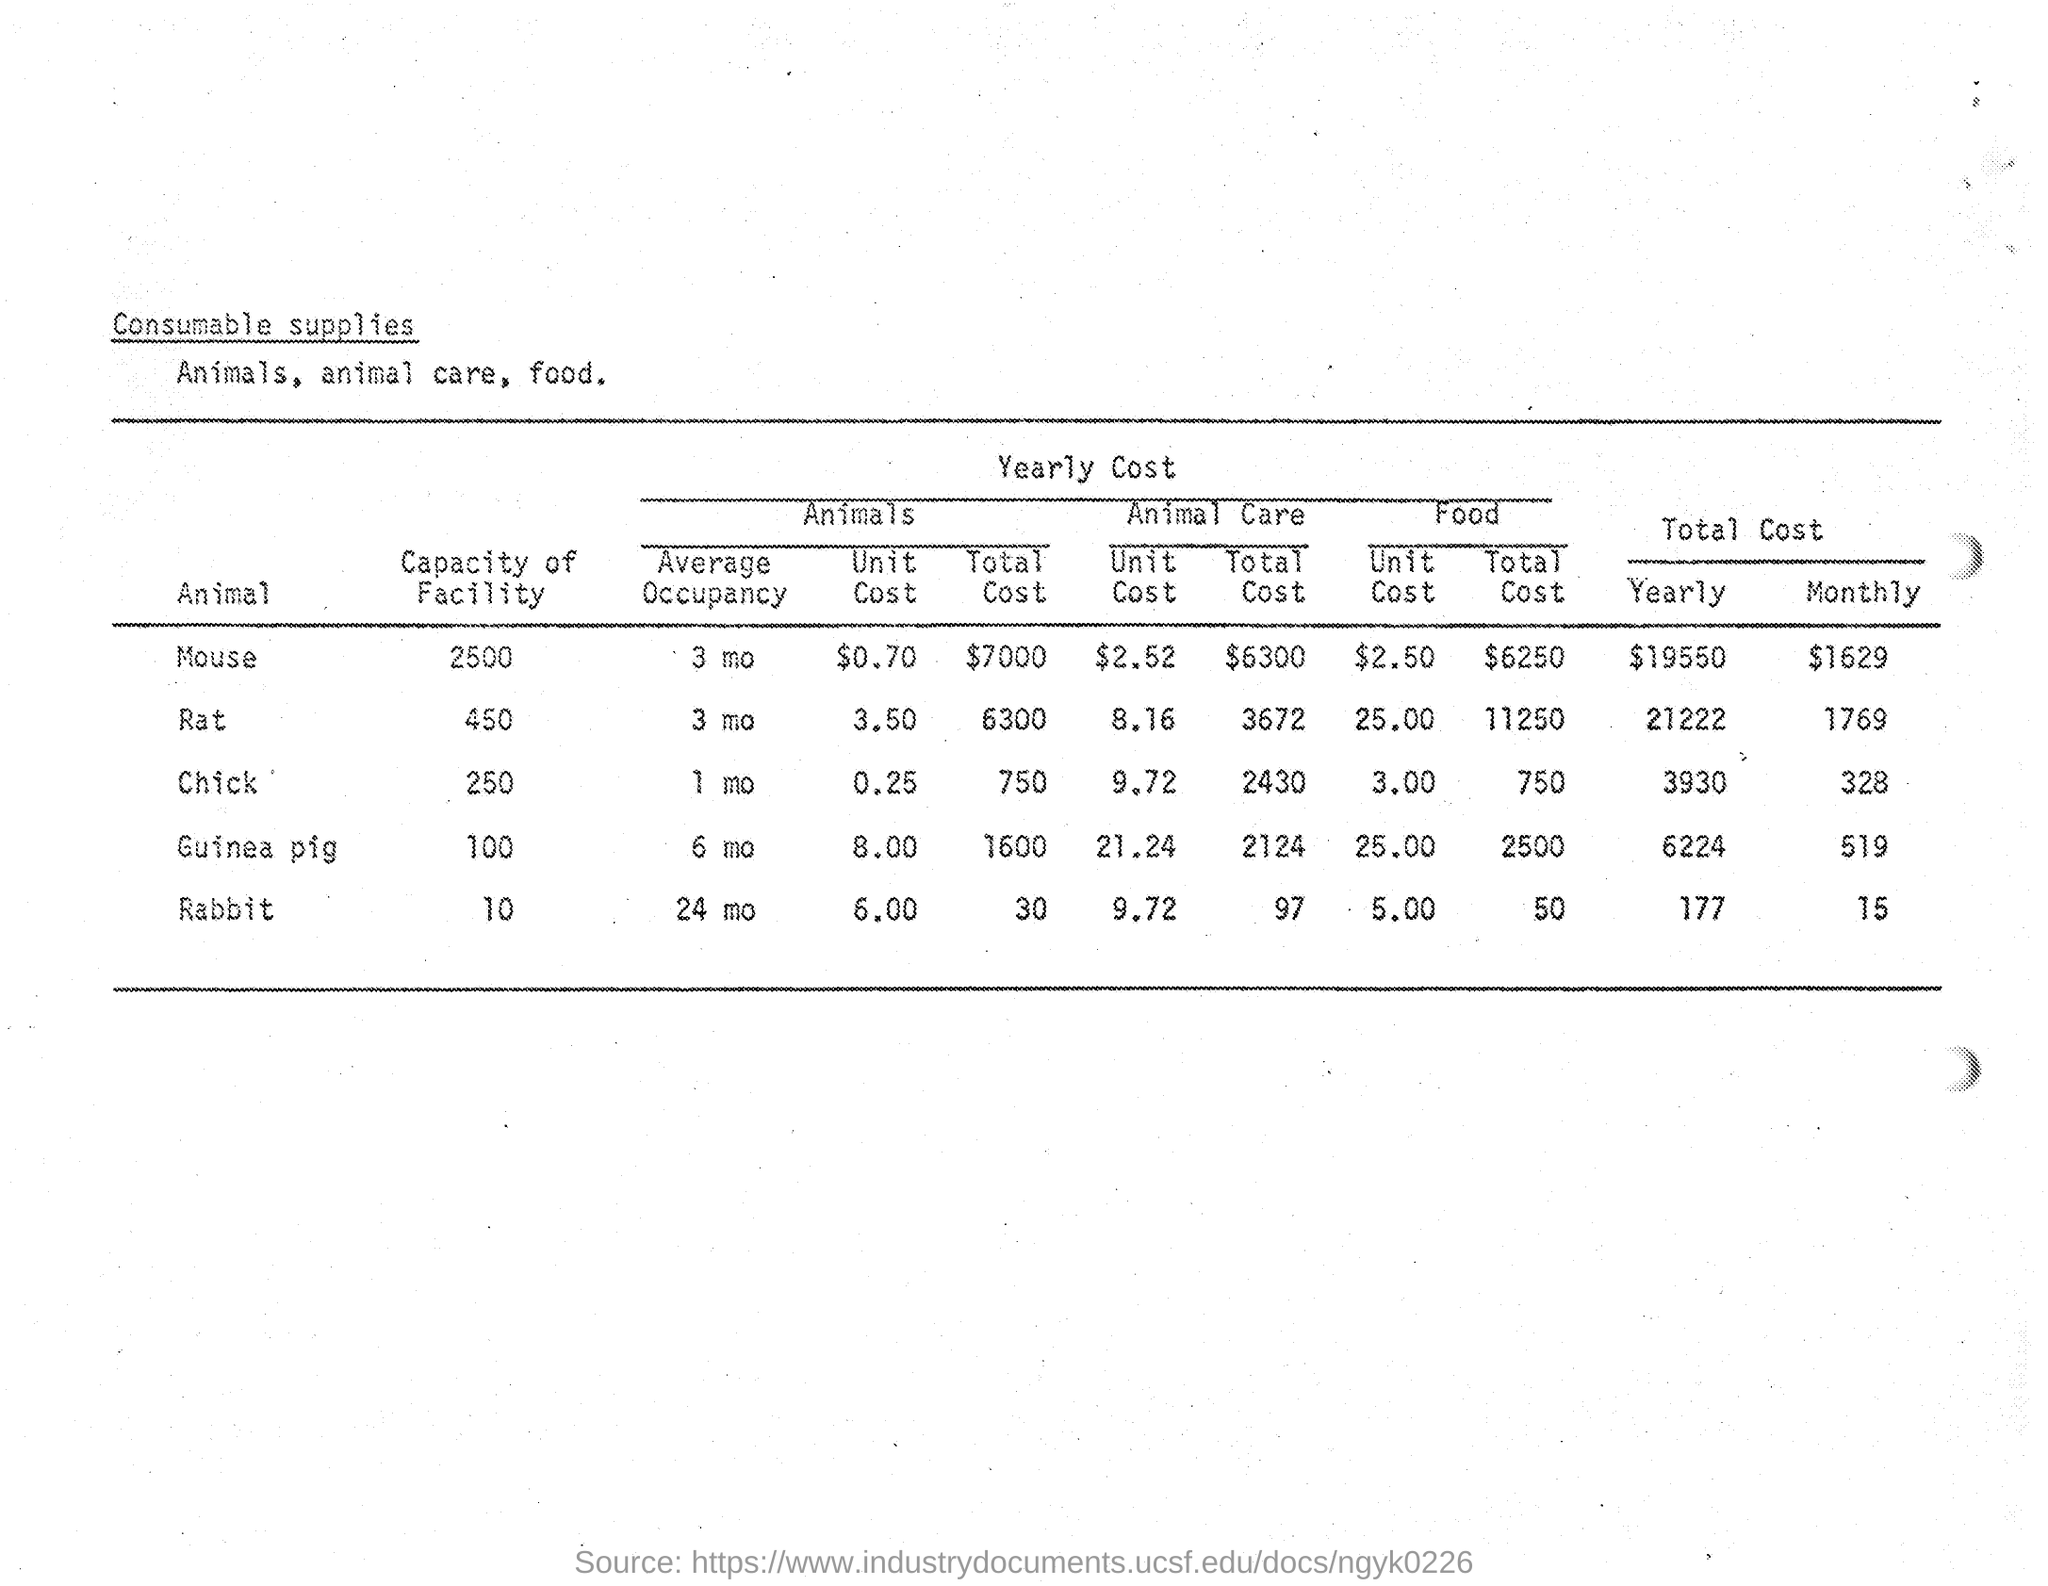Give some essential details in this illustration. The average occupancy of the Chick hotel for one month is [insert value]. The total monthly cost of Mouse is 1,629 dollars. 